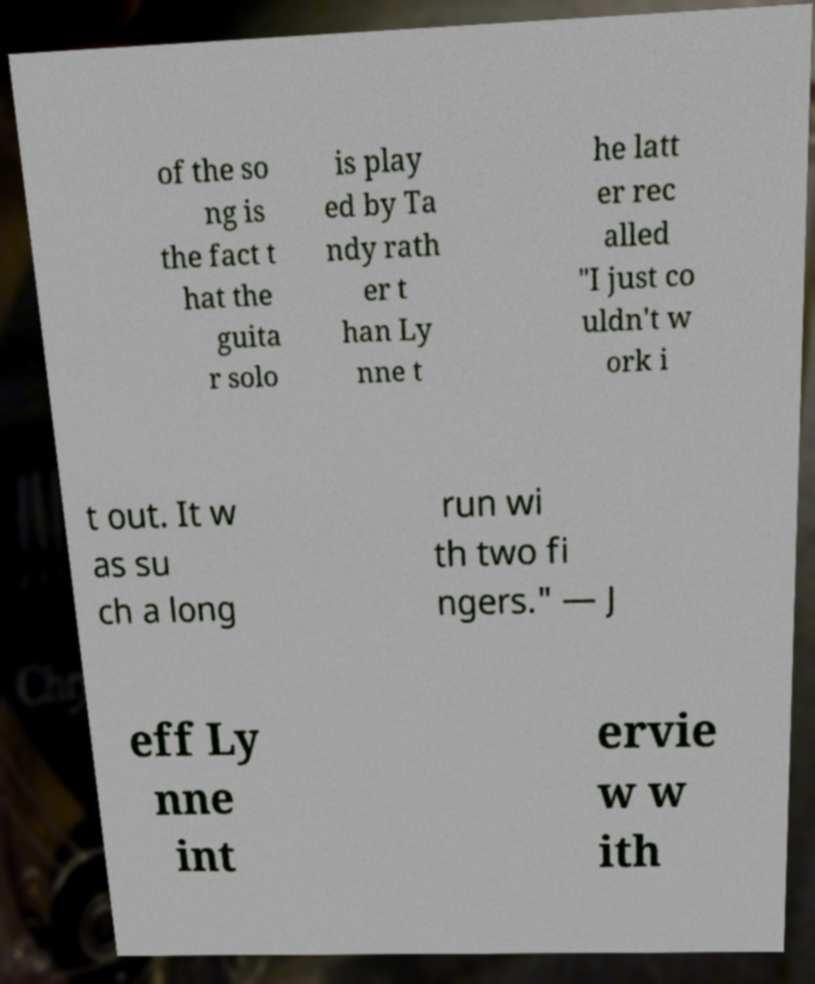Could you assist in decoding the text presented in this image and type it out clearly? of the so ng is the fact t hat the guita r solo is play ed by Ta ndy rath er t han Ly nne t he latt er rec alled "I just co uldn't w ork i t out. It w as su ch a long run wi th two fi ngers." — J eff Ly nne int ervie w w ith 